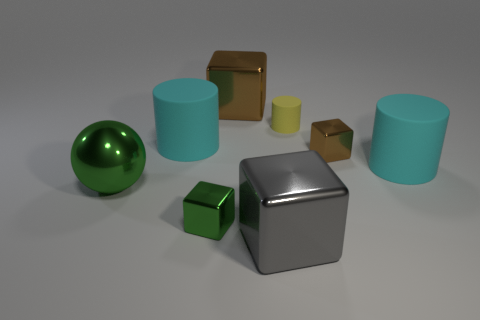Is the shape of the tiny object on the left side of the yellow matte thing the same as the cyan rubber thing to the right of the big brown metallic object? no 